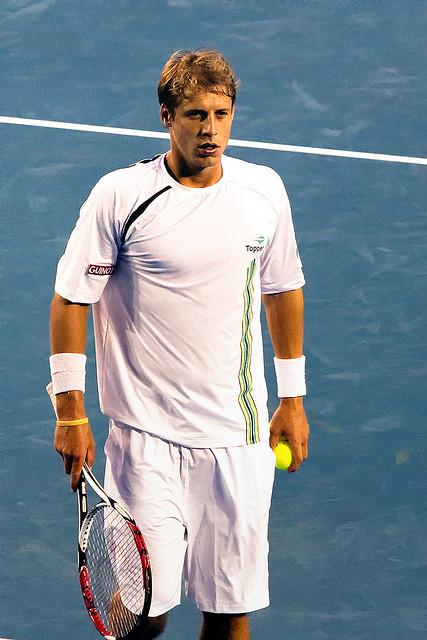Why does he have his forearms wrapped? Please explain your reasoning. to strengthen. He wants to be more powerful 